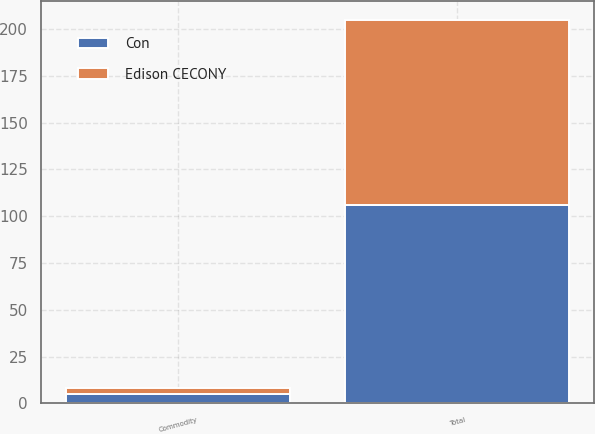Convert chart to OTSL. <chart><loc_0><loc_0><loc_500><loc_500><stacked_bar_chart><ecel><fcel>Total<fcel>Commodity<nl><fcel>Con<fcel>106<fcel>5<nl><fcel>Edison CECONY<fcel>99<fcel>3<nl></chart> 